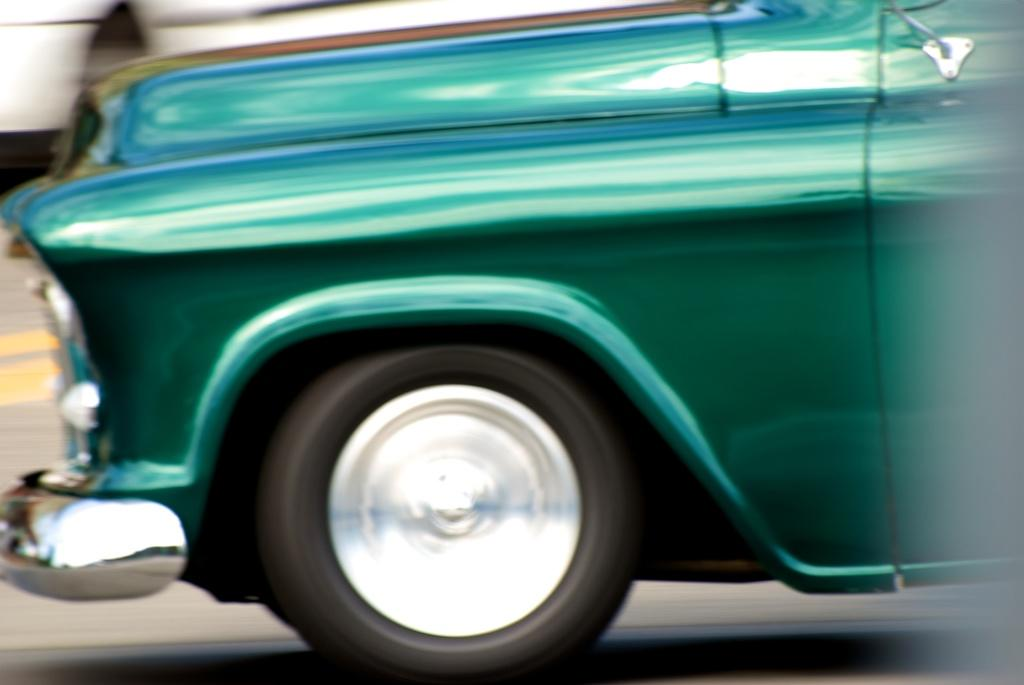What is the main subject of the image? The main subject of the image is a car. Where is the car located in the image? The car is on the road. Can you see a boy running on the road next to the car in the image? There is no boy running on the road next to the car in the image. 